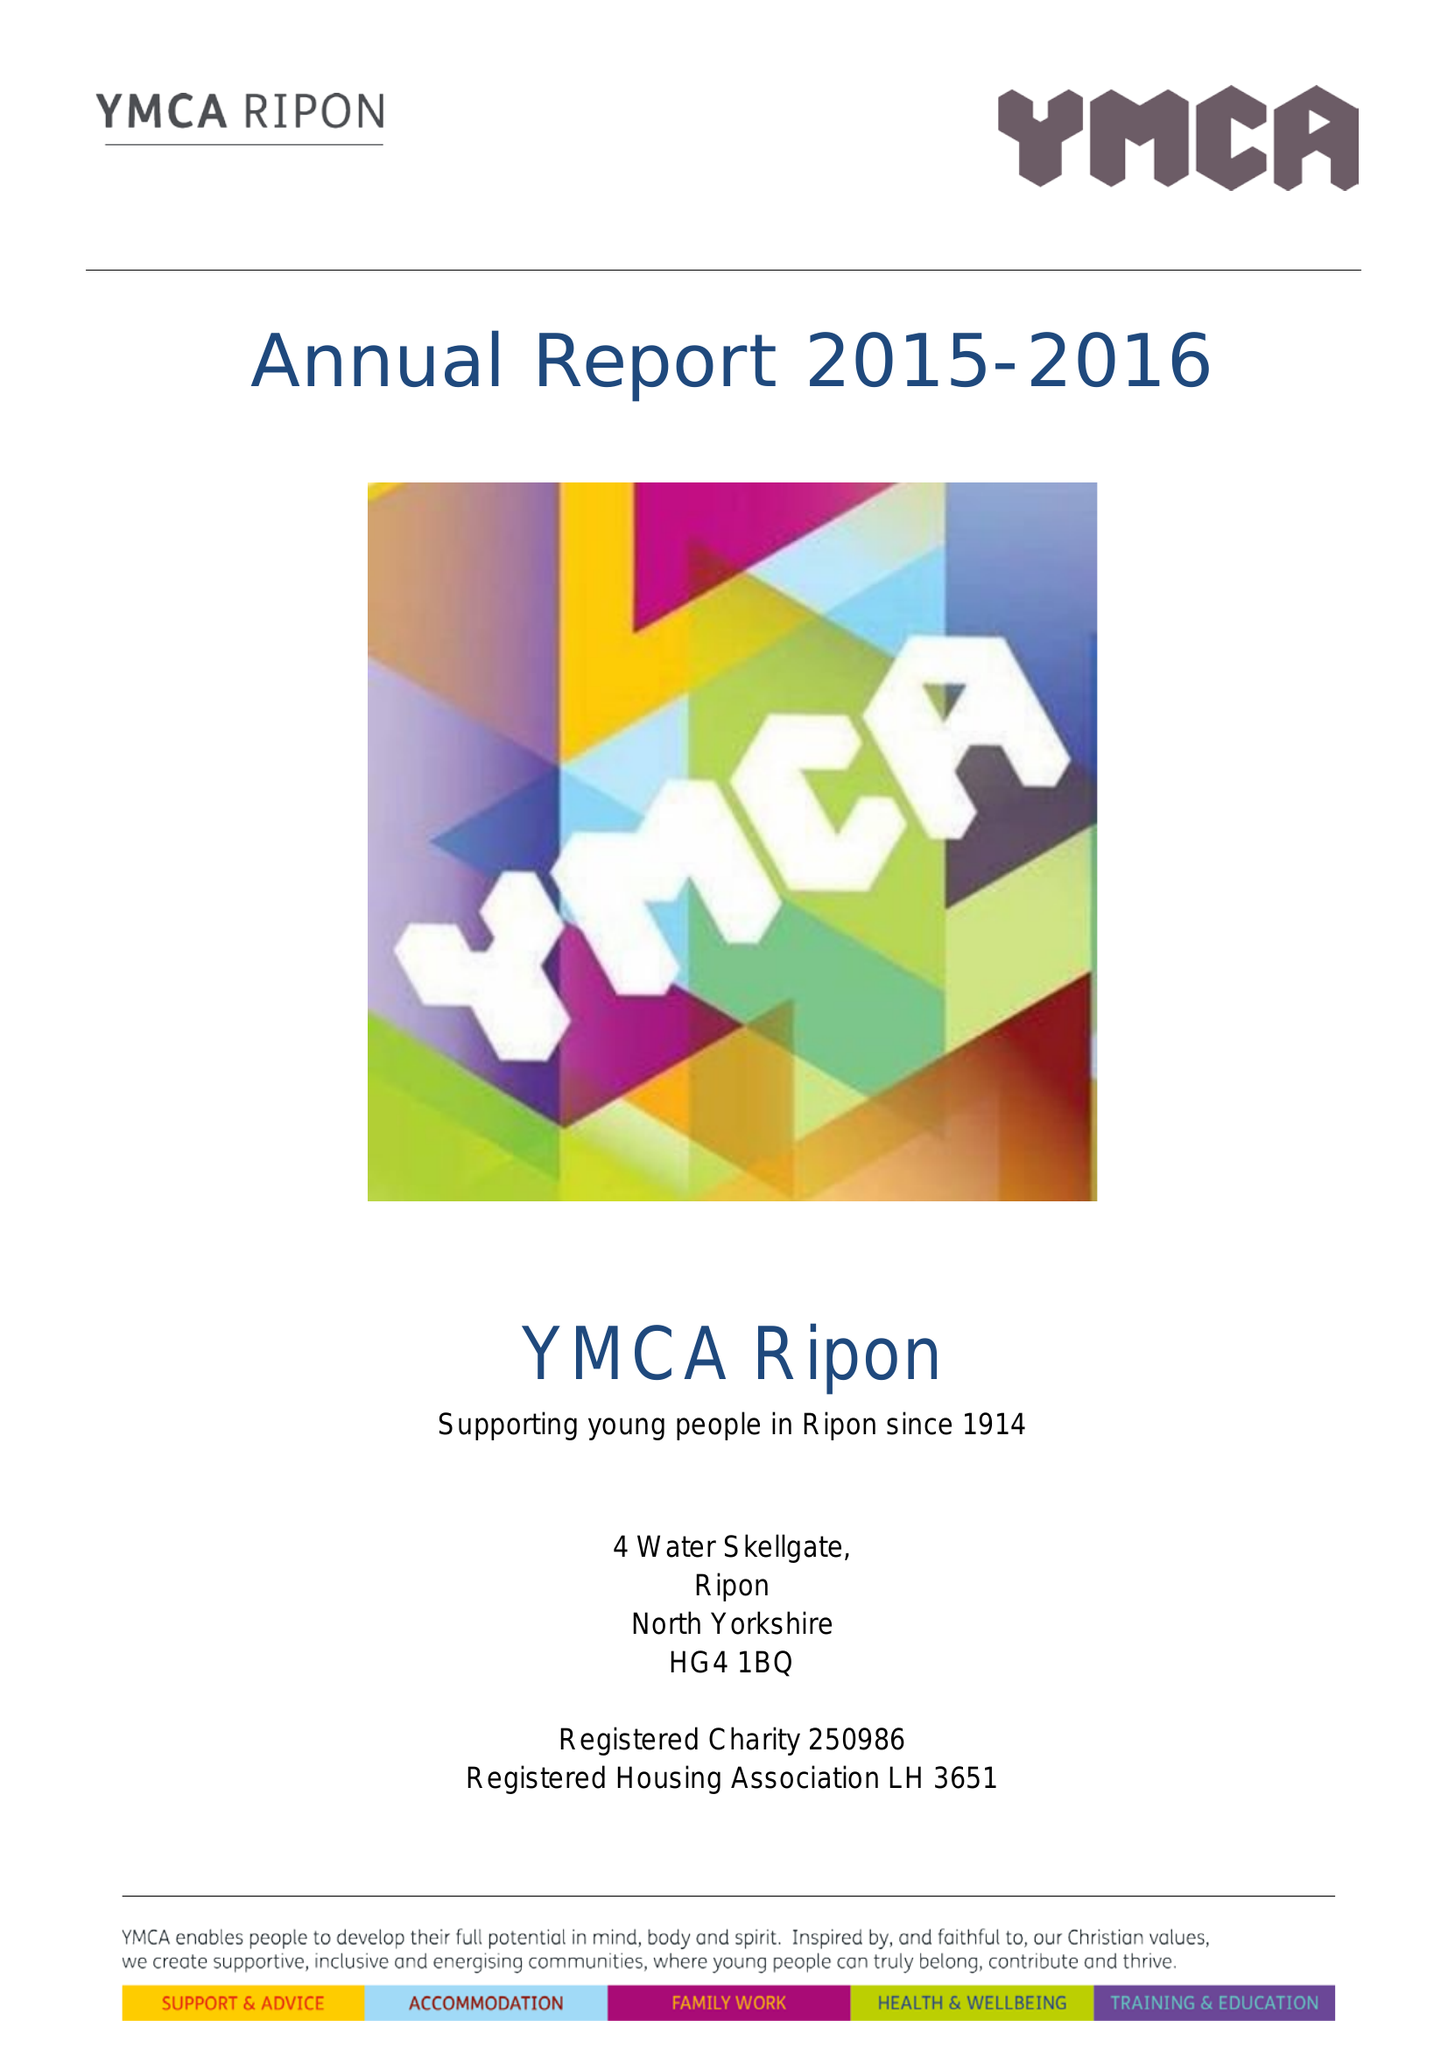What is the value for the address__postcode?
Answer the question using a single word or phrase. HG4 1BQ 